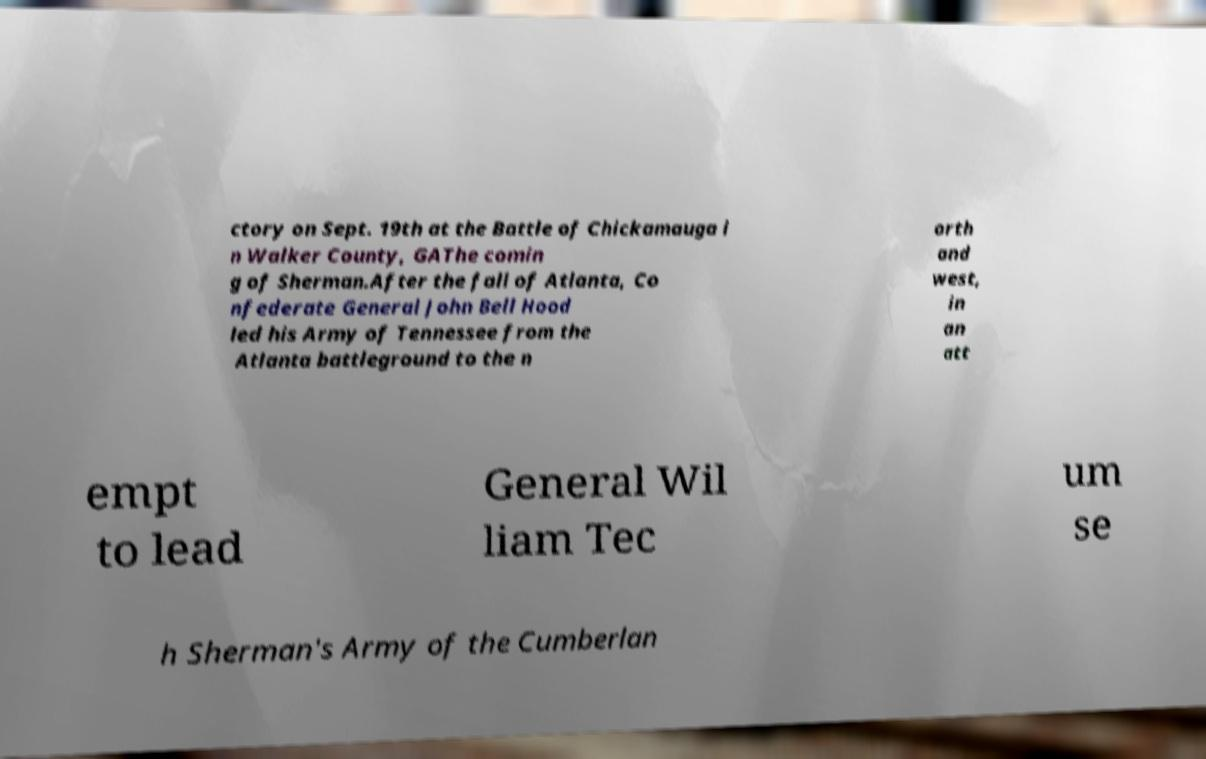Please identify and transcribe the text found in this image. ctory on Sept. 19th at the Battle of Chickamauga i n Walker County, GAThe comin g of Sherman.After the fall of Atlanta, Co nfederate General John Bell Hood led his Army of Tennessee from the Atlanta battleground to the n orth and west, in an att empt to lead General Wil liam Tec um se h Sherman's Army of the Cumberlan 